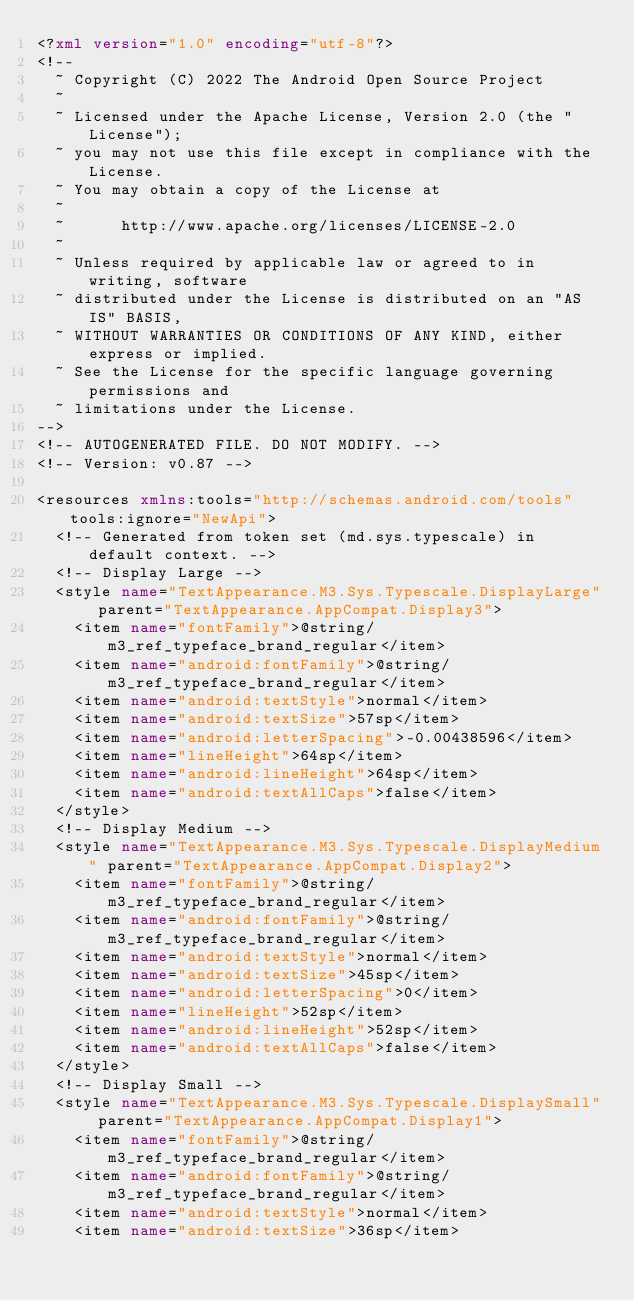Convert code to text. <code><loc_0><loc_0><loc_500><loc_500><_XML_><?xml version="1.0" encoding="utf-8"?>
<!--
  ~ Copyright (C) 2022 The Android Open Source Project
  ~
  ~ Licensed under the Apache License, Version 2.0 (the "License");
  ~ you may not use this file except in compliance with the License.
  ~ You may obtain a copy of the License at
  ~
  ~      http://www.apache.org/licenses/LICENSE-2.0
  ~
  ~ Unless required by applicable law or agreed to in writing, software
  ~ distributed under the License is distributed on an "AS IS" BASIS,
  ~ WITHOUT WARRANTIES OR CONDITIONS OF ANY KIND, either express or implied.
  ~ See the License for the specific language governing permissions and
  ~ limitations under the License.
-->
<!-- AUTOGENERATED FILE. DO NOT MODIFY. -->
<!-- Version: v0.87 -->

<resources xmlns:tools="http://schemas.android.com/tools" tools:ignore="NewApi">
  <!-- Generated from token set (md.sys.typescale) in default context. -->
  <!-- Display Large -->
  <style name="TextAppearance.M3.Sys.Typescale.DisplayLarge" parent="TextAppearance.AppCompat.Display3">
    <item name="fontFamily">@string/m3_ref_typeface_brand_regular</item>
    <item name="android:fontFamily">@string/m3_ref_typeface_brand_regular</item>
    <item name="android:textStyle">normal</item>
    <item name="android:textSize">57sp</item>
    <item name="android:letterSpacing">-0.00438596</item>
    <item name="lineHeight">64sp</item>
    <item name="android:lineHeight">64sp</item>
    <item name="android:textAllCaps">false</item>
  </style>
  <!-- Display Medium -->
  <style name="TextAppearance.M3.Sys.Typescale.DisplayMedium" parent="TextAppearance.AppCompat.Display2">
    <item name="fontFamily">@string/m3_ref_typeface_brand_regular</item>
    <item name="android:fontFamily">@string/m3_ref_typeface_brand_regular</item>
    <item name="android:textStyle">normal</item>
    <item name="android:textSize">45sp</item>
    <item name="android:letterSpacing">0</item>
    <item name="lineHeight">52sp</item>
    <item name="android:lineHeight">52sp</item>
    <item name="android:textAllCaps">false</item>
  </style>
  <!-- Display Small -->
  <style name="TextAppearance.M3.Sys.Typescale.DisplaySmall" parent="TextAppearance.AppCompat.Display1">
    <item name="fontFamily">@string/m3_ref_typeface_brand_regular</item>
    <item name="android:fontFamily">@string/m3_ref_typeface_brand_regular</item>
    <item name="android:textStyle">normal</item>
    <item name="android:textSize">36sp</item></code> 